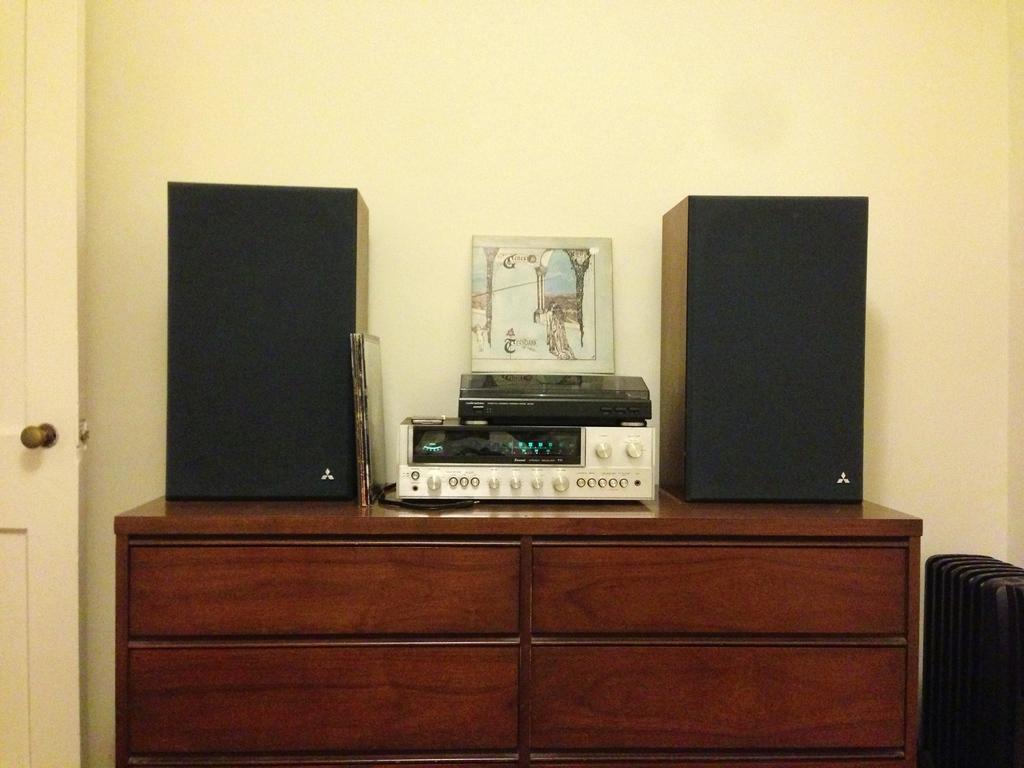Please provide a concise description of this image. In this image I can see the music player and the sound boxes on the cardboard box. The card box is in brown color. I can also see the photos on the player. In the background I can see the cream color wall. 